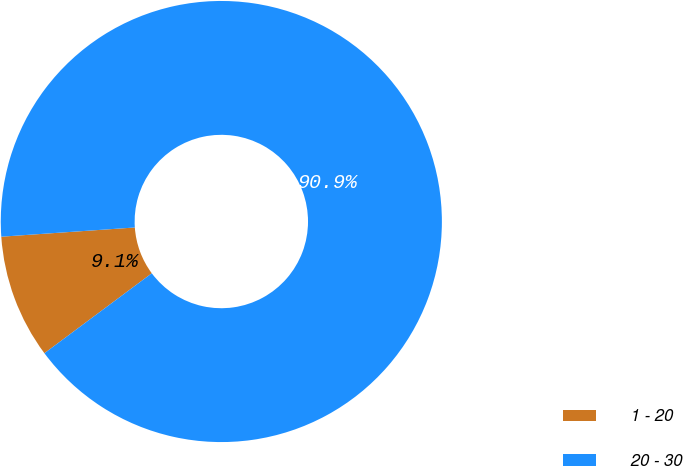Convert chart. <chart><loc_0><loc_0><loc_500><loc_500><pie_chart><fcel>1 - 20<fcel>20 - 30<nl><fcel>9.09%<fcel>90.91%<nl></chart> 